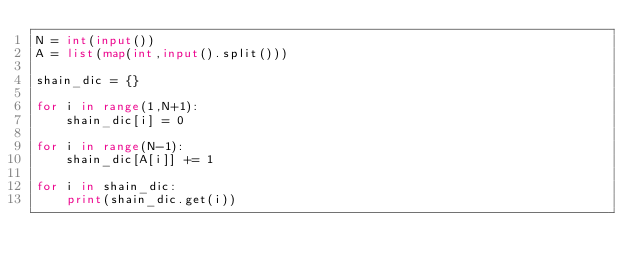Convert code to text. <code><loc_0><loc_0><loc_500><loc_500><_Python_>N = int(input())
A = list(map(int,input().split()))

shain_dic = {}

for i in range(1,N+1):
    shain_dic[i] = 0

for i in range(N-1):
    shain_dic[A[i]] += 1

for i in shain_dic:
    print(shain_dic.get(i))</code> 